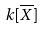<formula> <loc_0><loc_0><loc_500><loc_500>k [ \overline { X } ]</formula> 